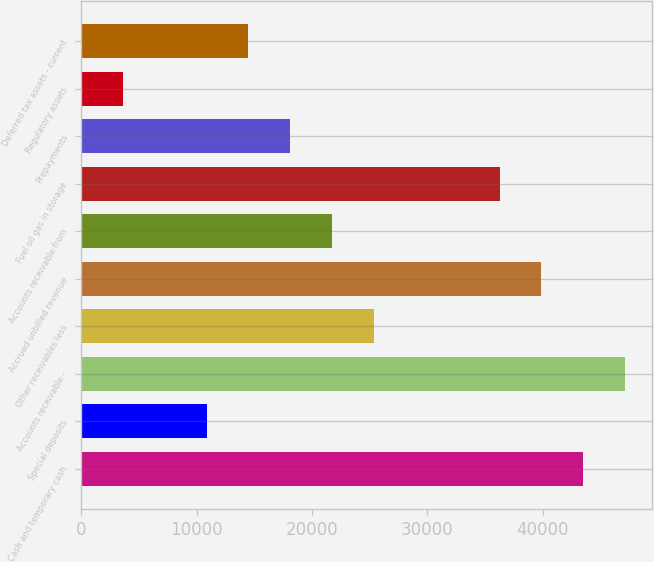Convert chart. <chart><loc_0><loc_0><loc_500><loc_500><bar_chart><fcel>Cash and temporary cash<fcel>Special deposits<fcel>Accounts receivable -<fcel>Other receivables less<fcel>Accrued unbilled revenue<fcel>Accounts receivable from<fcel>Fuel oil gas in storage<fcel>Prepayments<fcel>Regulatory assets<fcel>Deferred tax assets - current<nl><fcel>43508.8<fcel>10880.2<fcel>47134.2<fcel>25381.8<fcel>39883.4<fcel>21756.4<fcel>36258<fcel>18131<fcel>3629.4<fcel>14505.6<nl></chart> 